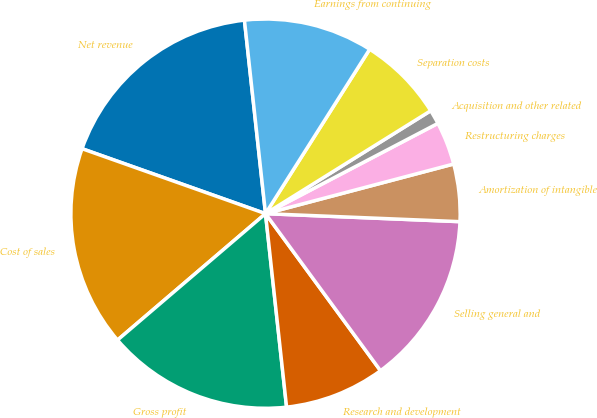<chart> <loc_0><loc_0><loc_500><loc_500><pie_chart><fcel>Net revenue<fcel>Cost of sales<fcel>Gross profit<fcel>Research and development<fcel>Selling general and<fcel>Amortization of intangible<fcel>Restructuring charges<fcel>Acquisition and other related<fcel>Separation costs<fcel>Earnings from continuing<nl><fcel>17.85%<fcel>16.66%<fcel>15.47%<fcel>8.33%<fcel>14.28%<fcel>4.76%<fcel>3.57%<fcel>1.19%<fcel>7.14%<fcel>10.71%<nl></chart> 